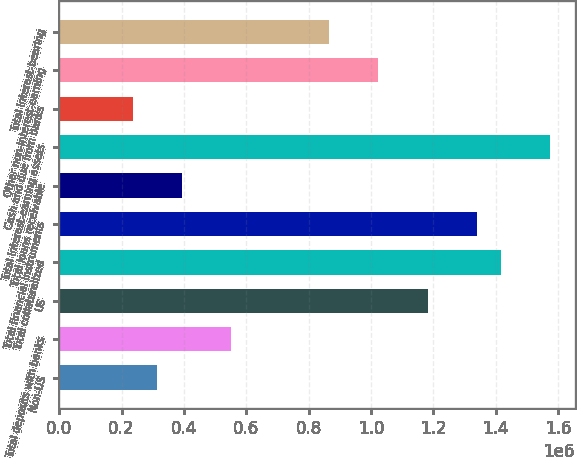<chart> <loc_0><loc_0><loc_500><loc_500><bar_chart><fcel>Non-US<fcel>Total deposits with banks<fcel>US<fcel>Total collateralized<fcel>Total financial instruments<fcel>Total loans receivable<fcel>Total interest-earning assets<fcel>Cash and due from banks<fcel>Other non-interest-earning<fcel>Total interest-bearing<nl><fcel>315076<fcel>551355<fcel>1.18143e+06<fcel>1.41771e+06<fcel>1.33895e+06<fcel>393836<fcel>1.57523e+06<fcel>236316<fcel>1.02391e+06<fcel>866395<nl></chart> 